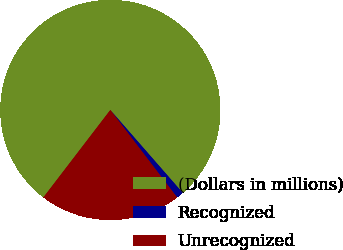Convert chart. <chart><loc_0><loc_0><loc_500><loc_500><pie_chart><fcel>(Dollars in millions)<fcel>Recognized<fcel>Unrecognized<nl><fcel>78.17%<fcel>1.05%<fcel>20.78%<nl></chart> 